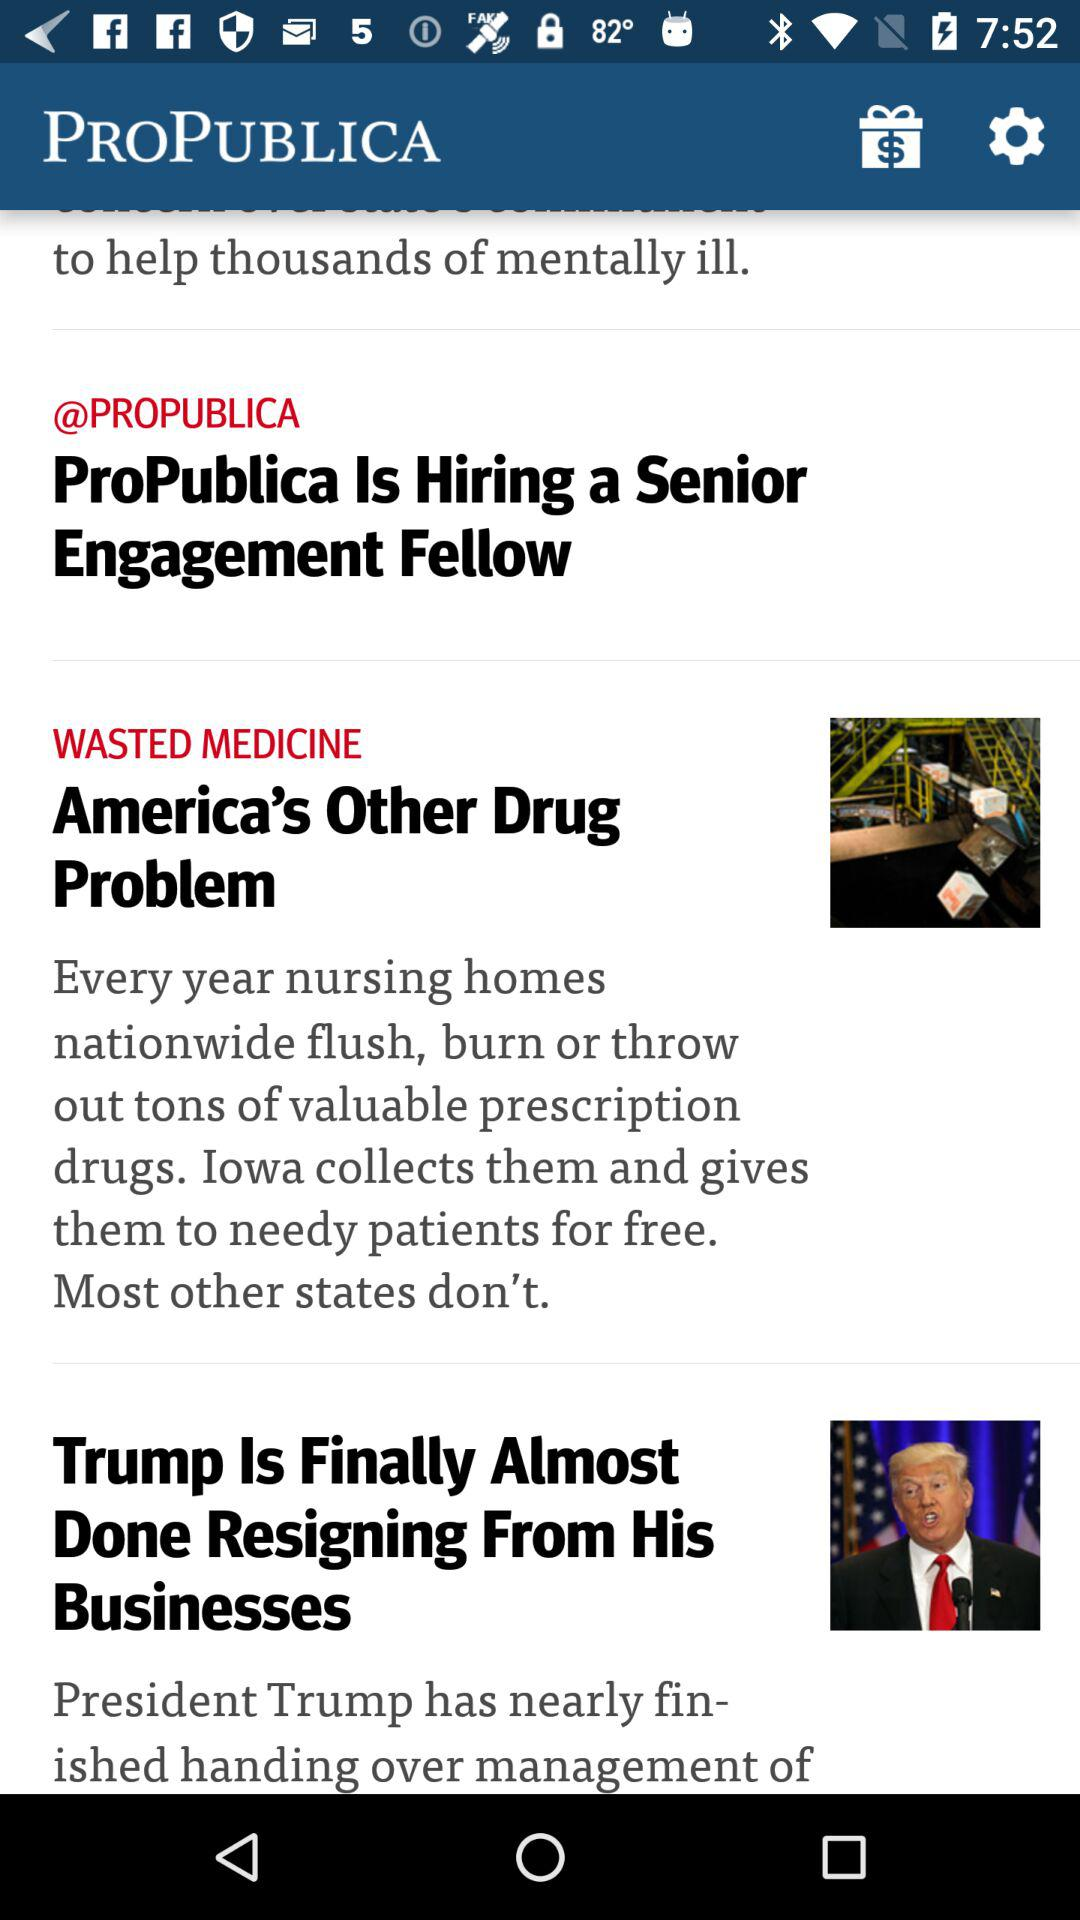What is the name of the application? The name of the application is "PROPUBLICA". 